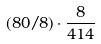<formula> <loc_0><loc_0><loc_500><loc_500>( 8 0 / 8 ) \cdot \frac { 8 } { 4 1 4 }</formula> 